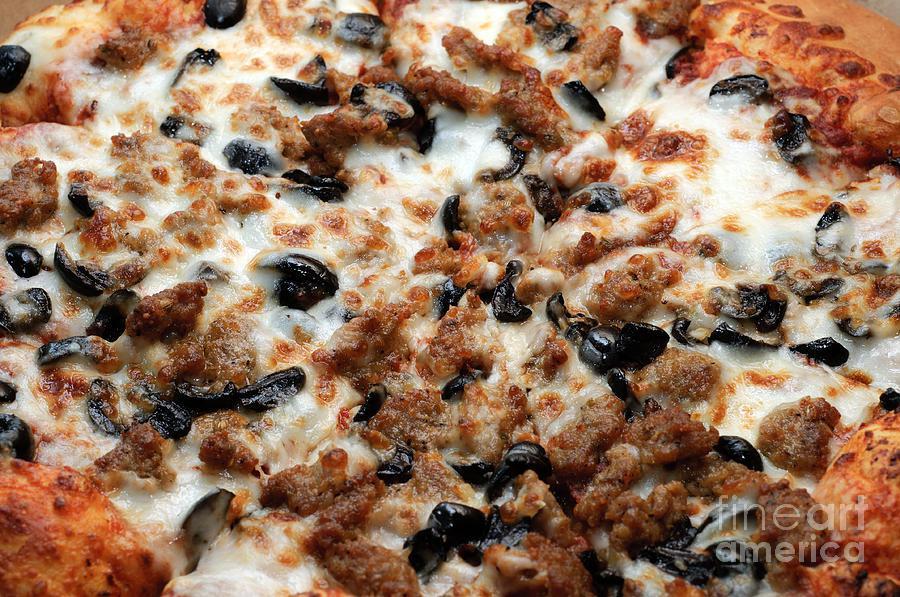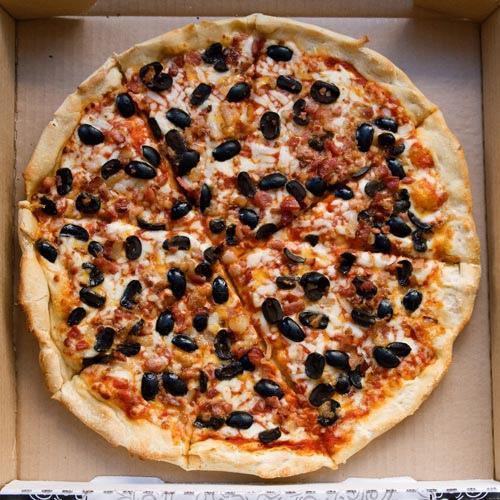The first image is the image on the left, the second image is the image on the right. Considering the images on both sides, is "One or more pizzas contain pepperoni." valid? Answer yes or no. No. The first image is the image on the left, the second image is the image on the right. Given the left and right images, does the statement "There are two circle pizzas uncut or all of it's slices are touching." hold true? Answer yes or no. Yes. 